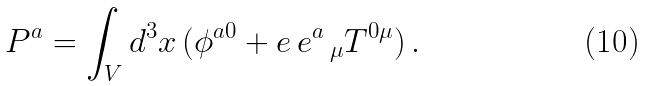Convert formula to latex. <formula><loc_0><loc_0><loc_500><loc_500>P ^ { a } = \int _ { V } d ^ { 3 } x \, ( \phi ^ { a 0 } + e \, e ^ { a } \, _ { \mu } T ^ { 0 \mu } ) \, .</formula> 